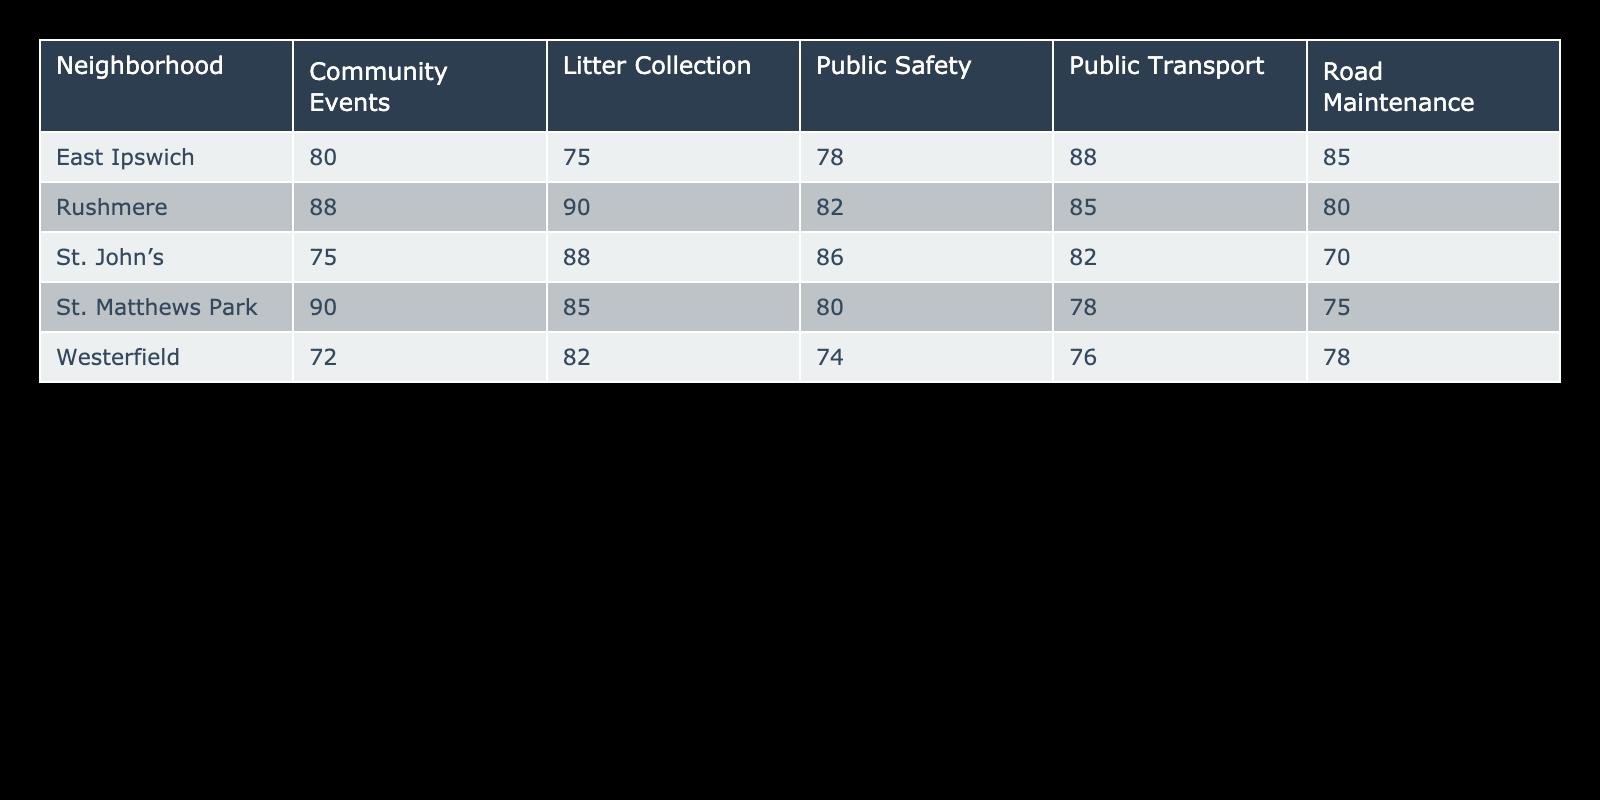What is the satisfaction rating for litter collection in Rushmere? According to the table, Rushmere's satisfaction rating for litter collection is 90.
Answer: 90 Which neighborhood has the highest satisfaction rating for community events? Looking at the table, Rushmere has the highest satisfaction rating for community events at 88.
Answer: Rushmere What is the average satisfaction rating for public transport across all neighborhoods? To find the average, I will sum the public transport ratings: 78 (St. Matthews Park) + 82 (St. John's) + 88 (East Ipswich) + 76 (Westerfield) + 85 (Rushmere) = 409. There are 5 neighborhoods, so the average is 409 / 5 = 81.8.
Answer: 81.8 Is the satisfaction rating for road maintenance in St. John's greater than the satisfaction rating for public safety in the same neighborhood? St. John's road maintenance rating is 70, and the public safety rating is 86. Since 70 is less than 86, the statement is false.
Answer: No What is the difference in satisfaction ratings for public safety between St. Matthews Park and East Ipswich? St. Matthews Park has a public safety rating of 80, and East Ipswich has a rating of 78. The difference is 80 - 78 = 2.
Answer: 2 Which service type has the lowest satisfaction rating in Westerfield? Examining the table, Westerfield has the lowest satisfaction rating for community events at 72.
Answer: Community Events What neighborhood has the lowest satisfaction rating for road maintenance among all neighborhoods? In the table, St. John's has the lowest satisfaction rating for road maintenance at 70, compared to others: St. Matthews Park (75), East Ipswich (85), Westerfield (78), and Rushmere (80).
Answer: St. John's Is the satisfaction rating for public transport in East Ipswich better than in St. Matthews Park? East Ipswich has a public transport rating of 88, while St. Matthews Park has a rating of 78. Since 88 is greater than 78, this statement is true.
Answer: Yes What is the overall average satisfaction rating for litter collection across all neighborhoods? The litter collection ratings are: 85 (St. Matthews Park) + 88 (St. John's) + 75 (East Ipswich) + 82 (Westerfield) + 90 (Rushmere) = 420. Dividing by the number of neighborhoods (5) gives an overall average of 420 / 5 = 84.
Answer: 84 